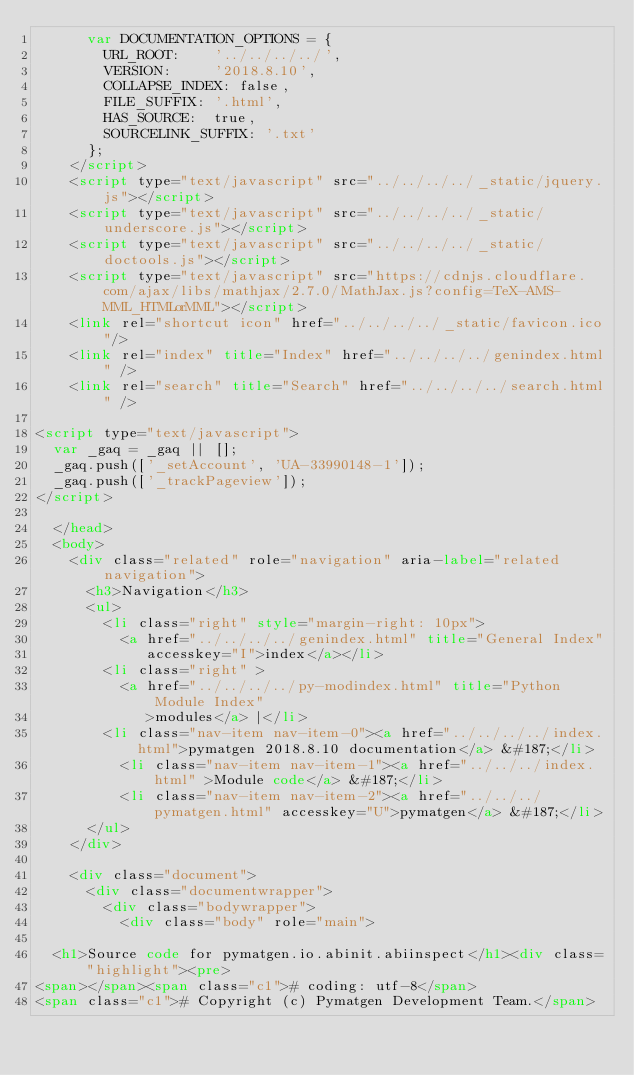<code> <loc_0><loc_0><loc_500><loc_500><_HTML_>      var DOCUMENTATION_OPTIONS = {
        URL_ROOT:    '../../../../',
        VERSION:     '2018.8.10',
        COLLAPSE_INDEX: false,
        FILE_SUFFIX: '.html',
        HAS_SOURCE:  true,
        SOURCELINK_SUFFIX: '.txt'
      };
    </script>
    <script type="text/javascript" src="../../../../_static/jquery.js"></script>
    <script type="text/javascript" src="../../../../_static/underscore.js"></script>
    <script type="text/javascript" src="../../../../_static/doctools.js"></script>
    <script type="text/javascript" src="https://cdnjs.cloudflare.com/ajax/libs/mathjax/2.7.0/MathJax.js?config=TeX-AMS-MML_HTMLorMML"></script>
    <link rel="shortcut icon" href="../../../../_static/favicon.ico"/>
    <link rel="index" title="Index" href="../../../../genindex.html" />
    <link rel="search" title="Search" href="../../../../search.html" />
 
<script type="text/javascript">
  var _gaq = _gaq || [];
  _gaq.push(['_setAccount', 'UA-33990148-1']);
  _gaq.push(['_trackPageview']);
</script>

  </head>
  <body>
    <div class="related" role="navigation" aria-label="related navigation">
      <h3>Navigation</h3>
      <ul>
        <li class="right" style="margin-right: 10px">
          <a href="../../../../genindex.html" title="General Index"
             accesskey="I">index</a></li>
        <li class="right" >
          <a href="../../../../py-modindex.html" title="Python Module Index"
             >modules</a> |</li>
        <li class="nav-item nav-item-0"><a href="../../../../index.html">pymatgen 2018.8.10 documentation</a> &#187;</li>
          <li class="nav-item nav-item-1"><a href="../../../index.html" >Module code</a> &#187;</li>
          <li class="nav-item nav-item-2"><a href="../../../pymatgen.html" accesskey="U">pymatgen</a> &#187;</li> 
      </ul>
    </div>  

    <div class="document">
      <div class="documentwrapper">
        <div class="bodywrapper">
          <div class="body" role="main">
            
  <h1>Source code for pymatgen.io.abinit.abiinspect</h1><div class="highlight"><pre>
<span></span><span class="c1"># coding: utf-8</span>
<span class="c1"># Copyright (c) Pymatgen Development Team.</span></code> 